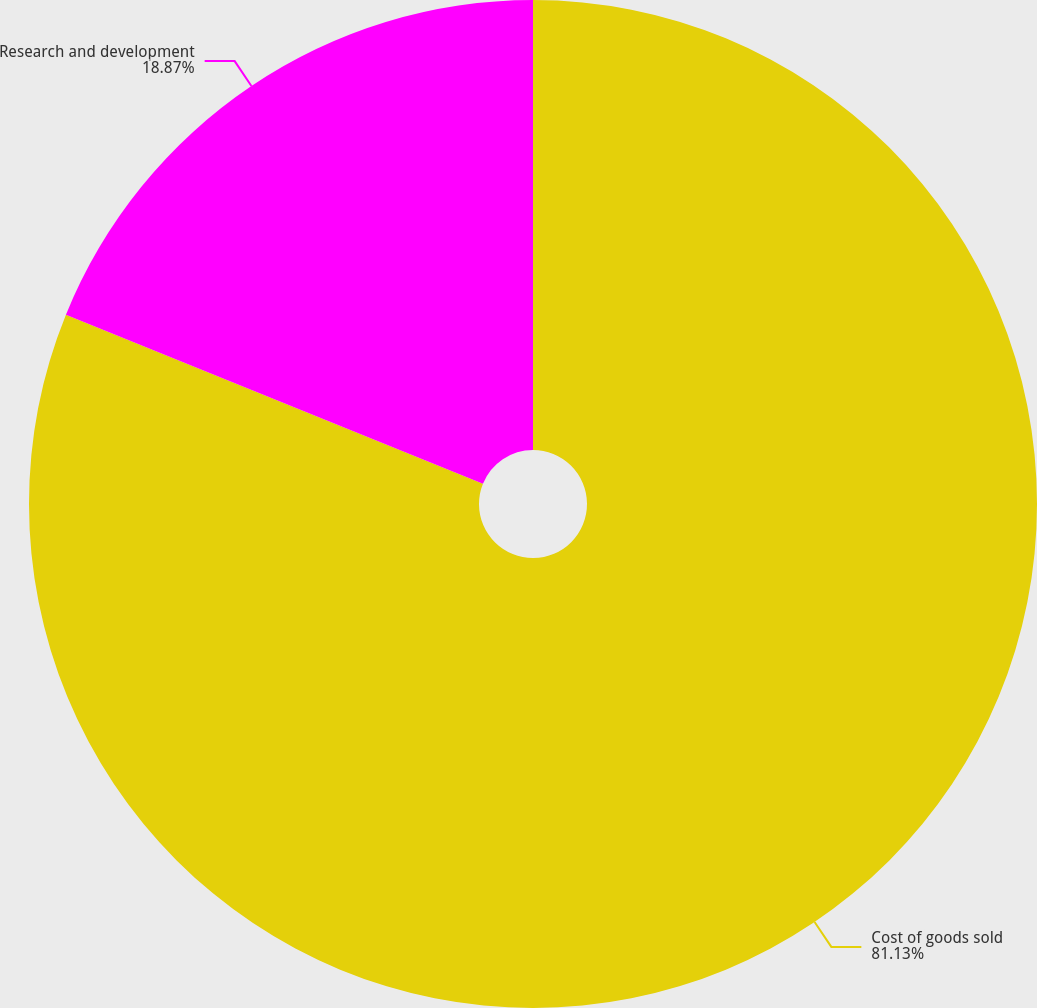Convert chart. <chart><loc_0><loc_0><loc_500><loc_500><pie_chart><fcel>Cost of goods sold<fcel>Research and development<nl><fcel>81.13%<fcel>18.87%<nl></chart> 